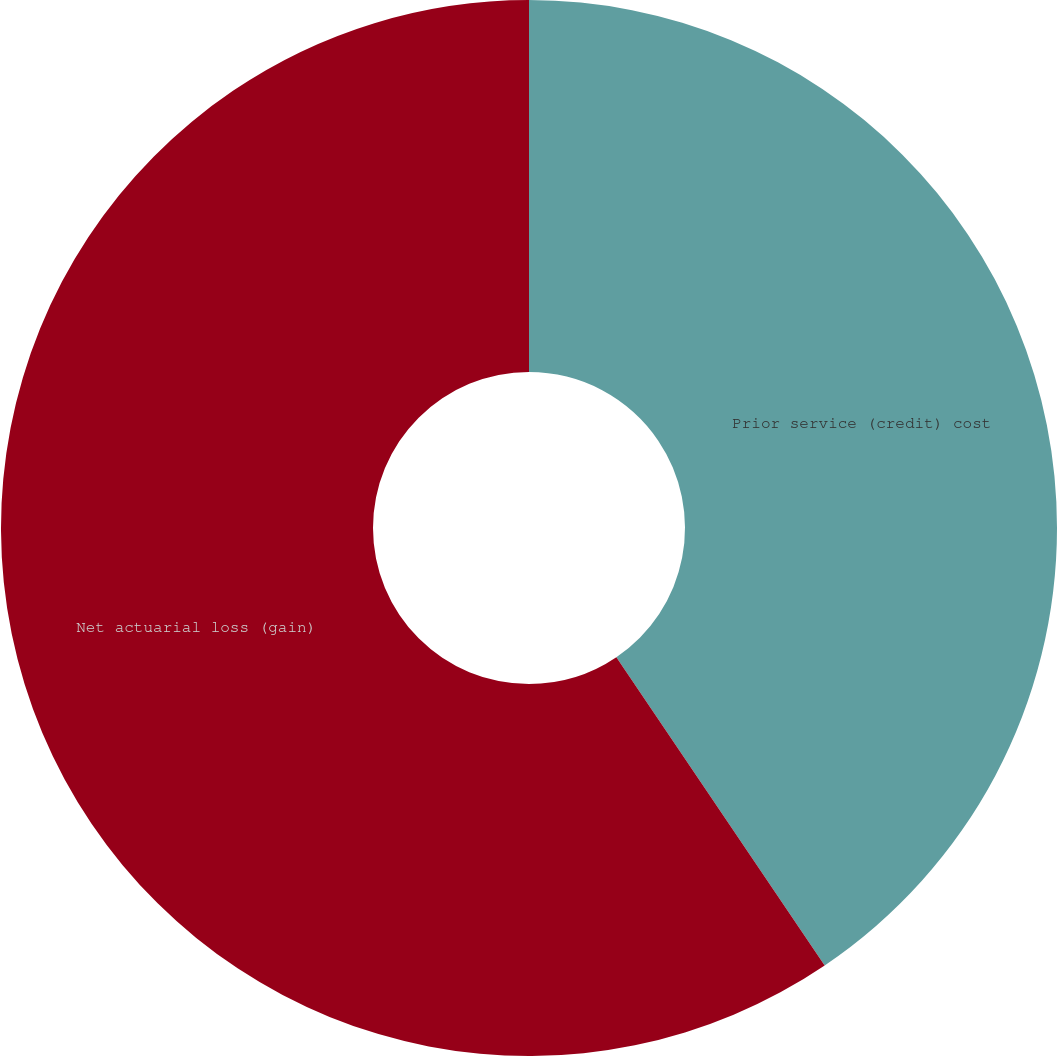Convert chart. <chart><loc_0><loc_0><loc_500><loc_500><pie_chart><fcel>Prior service (credit) cost<fcel>Net actuarial loss (gain)<nl><fcel>40.54%<fcel>59.46%<nl></chart> 